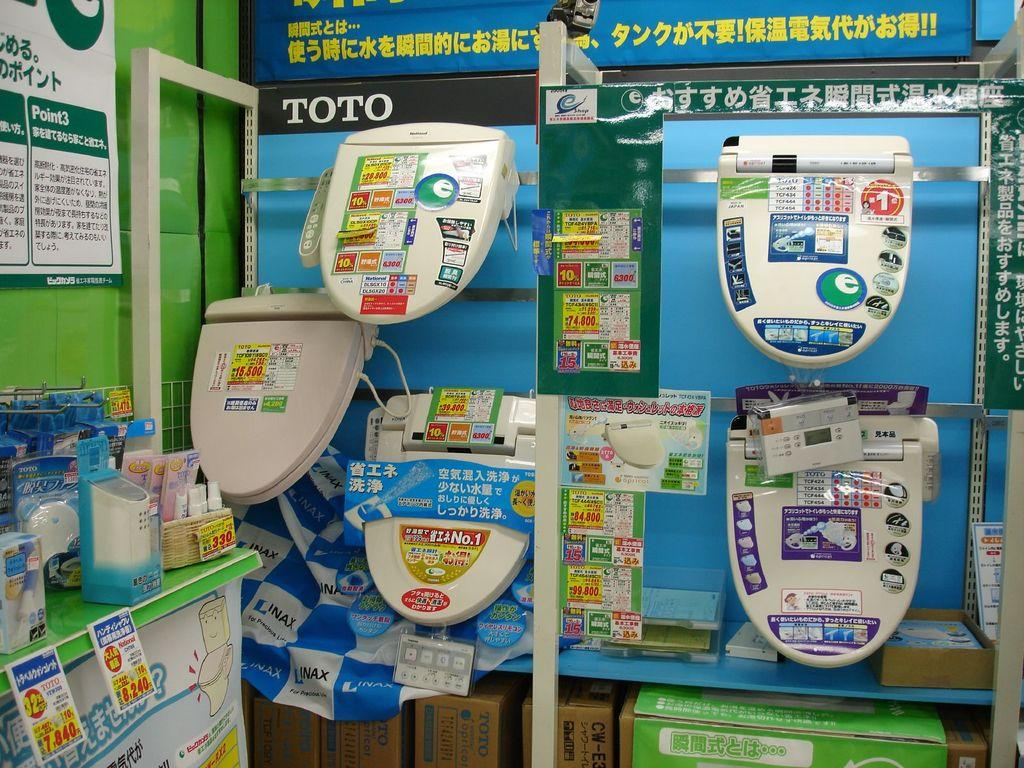<image>
Offer a succinct explanation of the picture presented. A display of Toto toilet lids hanging against a blue backdrop. 